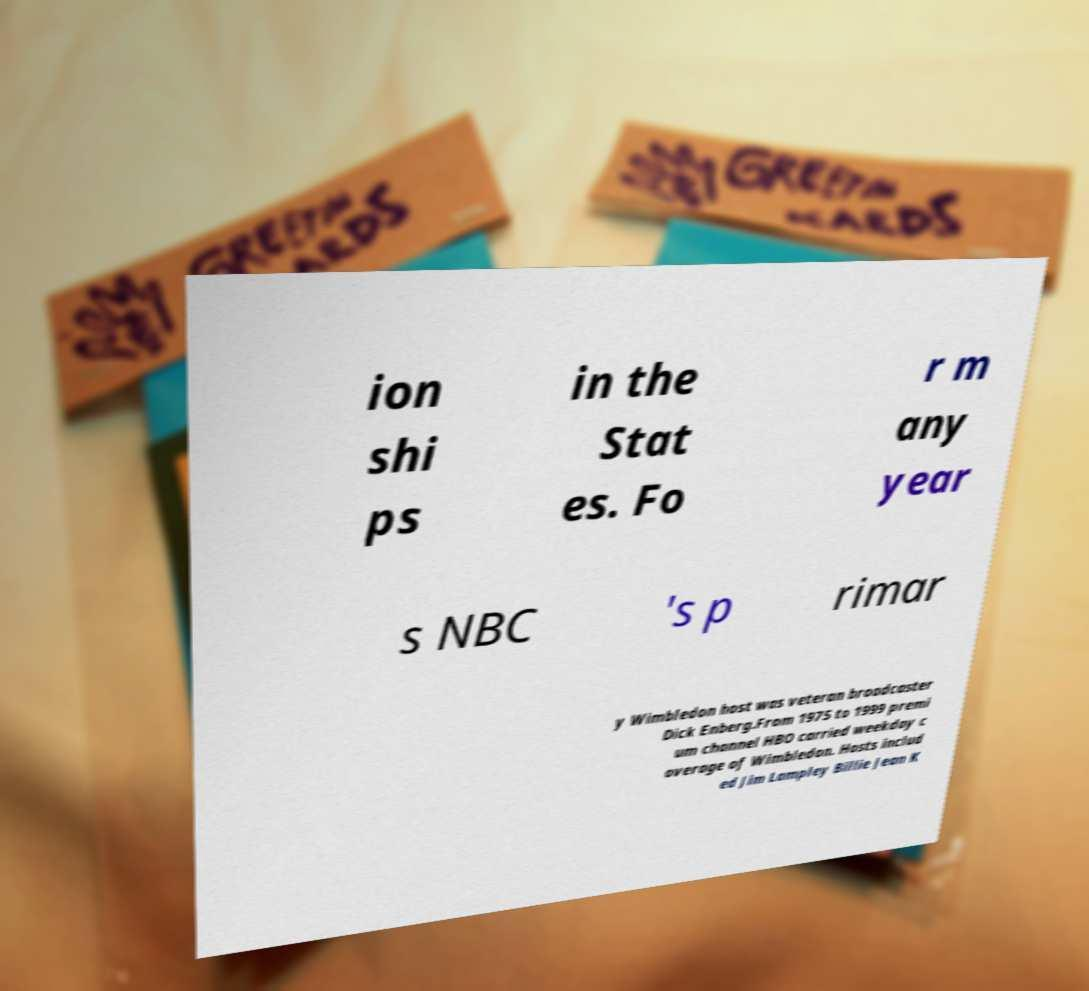For documentation purposes, I need the text within this image transcribed. Could you provide that? ion shi ps in the Stat es. Fo r m any year s NBC 's p rimar y Wimbledon host was veteran broadcaster Dick Enberg.From 1975 to 1999 premi um channel HBO carried weekday c overage of Wimbledon. Hosts includ ed Jim Lampley Billie Jean K 